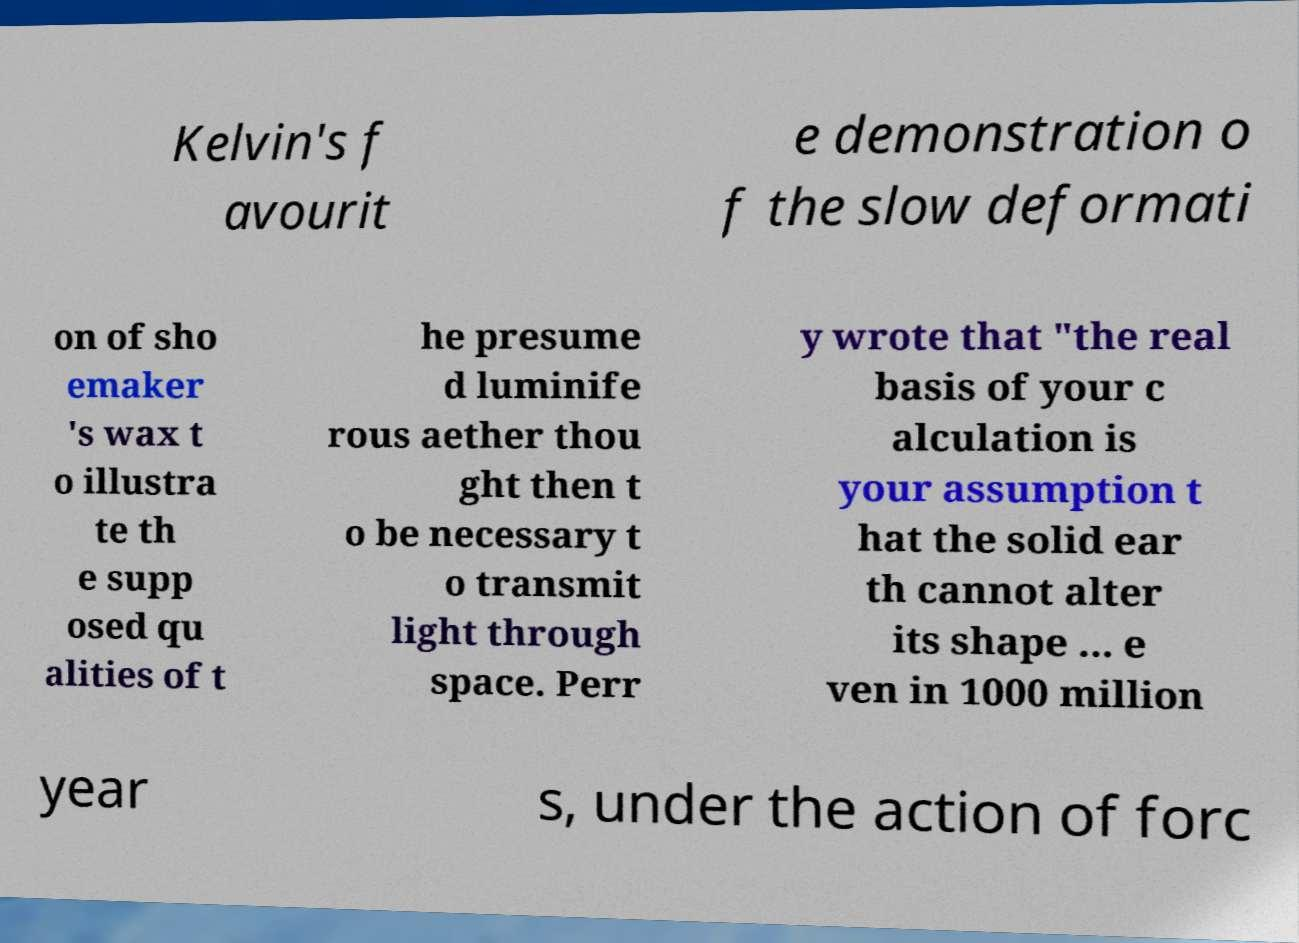I need the written content from this picture converted into text. Can you do that? Kelvin's f avourit e demonstration o f the slow deformati on of sho emaker 's wax t o illustra te th e supp osed qu alities of t he presume d luminife rous aether thou ght then t o be necessary t o transmit light through space. Perr y wrote that "the real basis of your c alculation is your assumption t hat the solid ear th cannot alter its shape ... e ven in 1000 million year s, under the action of forc 